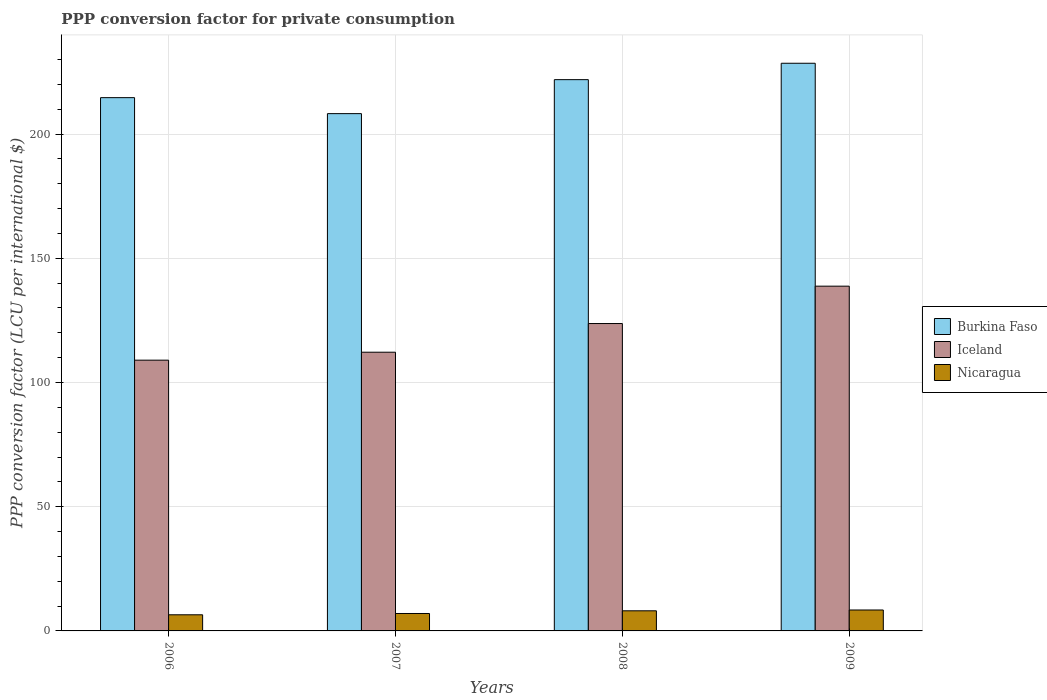How many different coloured bars are there?
Your response must be concise. 3. Are the number of bars per tick equal to the number of legend labels?
Keep it short and to the point. Yes. Are the number of bars on each tick of the X-axis equal?
Give a very brief answer. Yes. What is the label of the 2nd group of bars from the left?
Give a very brief answer. 2007. What is the PPP conversion factor for private consumption in Iceland in 2006?
Keep it short and to the point. 108.99. Across all years, what is the maximum PPP conversion factor for private consumption in Iceland?
Your response must be concise. 138.78. Across all years, what is the minimum PPP conversion factor for private consumption in Nicaragua?
Provide a succinct answer. 6.49. What is the total PPP conversion factor for private consumption in Nicaragua in the graph?
Provide a succinct answer. 30.04. What is the difference between the PPP conversion factor for private consumption in Iceland in 2008 and that in 2009?
Ensure brevity in your answer.  -15.04. What is the difference between the PPP conversion factor for private consumption in Burkina Faso in 2007 and the PPP conversion factor for private consumption in Iceland in 2006?
Offer a terse response. 99.24. What is the average PPP conversion factor for private consumption in Iceland per year?
Your response must be concise. 120.92. In the year 2007, what is the difference between the PPP conversion factor for private consumption in Nicaragua and PPP conversion factor for private consumption in Iceland?
Offer a terse response. -105.17. What is the ratio of the PPP conversion factor for private consumption in Nicaragua in 2006 to that in 2008?
Your answer should be compact. 0.8. Is the difference between the PPP conversion factor for private consumption in Nicaragua in 2007 and 2009 greater than the difference between the PPP conversion factor for private consumption in Iceland in 2007 and 2009?
Offer a very short reply. Yes. What is the difference between the highest and the second highest PPP conversion factor for private consumption in Burkina Faso?
Give a very brief answer. 6.6. What is the difference between the highest and the lowest PPP conversion factor for private consumption in Burkina Faso?
Keep it short and to the point. 20.28. Is the sum of the PPP conversion factor for private consumption in Nicaragua in 2007 and 2009 greater than the maximum PPP conversion factor for private consumption in Burkina Faso across all years?
Your answer should be very brief. No. What does the 3rd bar from the left in 2007 represents?
Provide a succinct answer. Nicaragua. What does the 3rd bar from the right in 2006 represents?
Give a very brief answer. Burkina Faso. Is it the case that in every year, the sum of the PPP conversion factor for private consumption in Burkina Faso and PPP conversion factor for private consumption in Nicaragua is greater than the PPP conversion factor for private consumption in Iceland?
Your answer should be compact. Yes. How many bars are there?
Offer a very short reply. 12. Are all the bars in the graph horizontal?
Offer a terse response. No. How many years are there in the graph?
Ensure brevity in your answer.  4. What is the difference between two consecutive major ticks on the Y-axis?
Your answer should be compact. 50. Are the values on the major ticks of Y-axis written in scientific E-notation?
Your response must be concise. No. Does the graph contain grids?
Your answer should be very brief. Yes. How many legend labels are there?
Keep it short and to the point. 3. How are the legend labels stacked?
Make the answer very short. Vertical. What is the title of the graph?
Give a very brief answer. PPP conversion factor for private consumption. Does "Estonia" appear as one of the legend labels in the graph?
Your answer should be compact. No. What is the label or title of the X-axis?
Provide a short and direct response. Years. What is the label or title of the Y-axis?
Offer a terse response. PPP conversion factor (LCU per international $). What is the PPP conversion factor (LCU per international $) of Burkina Faso in 2006?
Provide a short and direct response. 214.66. What is the PPP conversion factor (LCU per international $) of Iceland in 2006?
Give a very brief answer. 108.99. What is the PPP conversion factor (LCU per international $) of Nicaragua in 2006?
Offer a terse response. 6.49. What is the PPP conversion factor (LCU per international $) in Burkina Faso in 2007?
Keep it short and to the point. 208.23. What is the PPP conversion factor (LCU per international $) in Iceland in 2007?
Keep it short and to the point. 112.19. What is the PPP conversion factor (LCU per international $) of Nicaragua in 2007?
Offer a very short reply. 7.02. What is the PPP conversion factor (LCU per international $) in Burkina Faso in 2008?
Your answer should be very brief. 221.91. What is the PPP conversion factor (LCU per international $) in Iceland in 2008?
Keep it short and to the point. 123.74. What is the PPP conversion factor (LCU per international $) in Nicaragua in 2008?
Offer a very short reply. 8.1. What is the PPP conversion factor (LCU per international $) of Burkina Faso in 2009?
Your answer should be compact. 228.51. What is the PPP conversion factor (LCU per international $) of Iceland in 2009?
Keep it short and to the point. 138.78. What is the PPP conversion factor (LCU per international $) of Nicaragua in 2009?
Your response must be concise. 8.43. Across all years, what is the maximum PPP conversion factor (LCU per international $) of Burkina Faso?
Your response must be concise. 228.51. Across all years, what is the maximum PPP conversion factor (LCU per international $) of Iceland?
Offer a terse response. 138.78. Across all years, what is the maximum PPP conversion factor (LCU per international $) of Nicaragua?
Your answer should be compact. 8.43. Across all years, what is the minimum PPP conversion factor (LCU per international $) in Burkina Faso?
Make the answer very short. 208.23. Across all years, what is the minimum PPP conversion factor (LCU per international $) of Iceland?
Ensure brevity in your answer.  108.99. Across all years, what is the minimum PPP conversion factor (LCU per international $) in Nicaragua?
Offer a very short reply. 6.49. What is the total PPP conversion factor (LCU per international $) in Burkina Faso in the graph?
Provide a succinct answer. 873.3. What is the total PPP conversion factor (LCU per international $) in Iceland in the graph?
Offer a very short reply. 483.7. What is the total PPP conversion factor (LCU per international $) of Nicaragua in the graph?
Give a very brief answer. 30.04. What is the difference between the PPP conversion factor (LCU per international $) in Burkina Faso in 2006 and that in 2007?
Your answer should be very brief. 6.44. What is the difference between the PPP conversion factor (LCU per international $) of Iceland in 2006 and that in 2007?
Offer a terse response. -3.2. What is the difference between the PPP conversion factor (LCU per international $) of Nicaragua in 2006 and that in 2007?
Your answer should be compact. -0.52. What is the difference between the PPP conversion factor (LCU per international $) in Burkina Faso in 2006 and that in 2008?
Your answer should be compact. -7.24. What is the difference between the PPP conversion factor (LCU per international $) of Iceland in 2006 and that in 2008?
Your response must be concise. -14.74. What is the difference between the PPP conversion factor (LCU per international $) in Nicaragua in 2006 and that in 2008?
Give a very brief answer. -1.6. What is the difference between the PPP conversion factor (LCU per international $) in Burkina Faso in 2006 and that in 2009?
Keep it short and to the point. -13.84. What is the difference between the PPP conversion factor (LCU per international $) of Iceland in 2006 and that in 2009?
Offer a very short reply. -29.79. What is the difference between the PPP conversion factor (LCU per international $) in Nicaragua in 2006 and that in 2009?
Give a very brief answer. -1.93. What is the difference between the PPP conversion factor (LCU per international $) of Burkina Faso in 2007 and that in 2008?
Ensure brevity in your answer.  -13.68. What is the difference between the PPP conversion factor (LCU per international $) of Iceland in 2007 and that in 2008?
Your answer should be compact. -11.54. What is the difference between the PPP conversion factor (LCU per international $) of Nicaragua in 2007 and that in 2008?
Give a very brief answer. -1.08. What is the difference between the PPP conversion factor (LCU per international $) of Burkina Faso in 2007 and that in 2009?
Provide a short and direct response. -20.28. What is the difference between the PPP conversion factor (LCU per international $) in Iceland in 2007 and that in 2009?
Your answer should be compact. -26.59. What is the difference between the PPP conversion factor (LCU per international $) of Nicaragua in 2007 and that in 2009?
Make the answer very short. -1.41. What is the difference between the PPP conversion factor (LCU per international $) in Burkina Faso in 2008 and that in 2009?
Your answer should be compact. -6.6. What is the difference between the PPP conversion factor (LCU per international $) of Iceland in 2008 and that in 2009?
Offer a very short reply. -15.04. What is the difference between the PPP conversion factor (LCU per international $) of Nicaragua in 2008 and that in 2009?
Your response must be concise. -0.33. What is the difference between the PPP conversion factor (LCU per international $) in Burkina Faso in 2006 and the PPP conversion factor (LCU per international $) in Iceland in 2007?
Ensure brevity in your answer.  102.47. What is the difference between the PPP conversion factor (LCU per international $) of Burkina Faso in 2006 and the PPP conversion factor (LCU per international $) of Nicaragua in 2007?
Provide a succinct answer. 207.65. What is the difference between the PPP conversion factor (LCU per international $) in Iceland in 2006 and the PPP conversion factor (LCU per international $) in Nicaragua in 2007?
Keep it short and to the point. 101.97. What is the difference between the PPP conversion factor (LCU per international $) in Burkina Faso in 2006 and the PPP conversion factor (LCU per international $) in Iceland in 2008?
Give a very brief answer. 90.93. What is the difference between the PPP conversion factor (LCU per international $) in Burkina Faso in 2006 and the PPP conversion factor (LCU per international $) in Nicaragua in 2008?
Offer a terse response. 206.57. What is the difference between the PPP conversion factor (LCU per international $) in Iceland in 2006 and the PPP conversion factor (LCU per international $) in Nicaragua in 2008?
Offer a terse response. 100.89. What is the difference between the PPP conversion factor (LCU per international $) of Burkina Faso in 2006 and the PPP conversion factor (LCU per international $) of Iceland in 2009?
Give a very brief answer. 75.88. What is the difference between the PPP conversion factor (LCU per international $) in Burkina Faso in 2006 and the PPP conversion factor (LCU per international $) in Nicaragua in 2009?
Make the answer very short. 206.24. What is the difference between the PPP conversion factor (LCU per international $) in Iceland in 2006 and the PPP conversion factor (LCU per international $) in Nicaragua in 2009?
Your answer should be compact. 100.56. What is the difference between the PPP conversion factor (LCU per international $) in Burkina Faso in 2007 and the PPP conversion factor (LCU per international $) in Iceland in 2008?
Your response must be concise. 84.49. What is the difference between the PPP conversion factor (LCU per international $) of Burkina Faso in 2007 and the PPP conversion factor (LCU per international $) of Nicaragua in 2008?
Ensure brevity in your answer.  200.13. What is the difference between the PPP conversion factor (LCU per international $) of Iceland in 2007 and the PPP conversion factor (LCU per international $) of Nicaragua in 2008?
Provide a succinct answer. 104.09. What is the difference between the PPP conversion factor (LCU per international $) in Burkina Faso in 2007 and the PPP conversion factor (LCU per international $) in Iceland in 2009?
Keep it short and to the point. 69.45. What is the difference between the PPP conversion factor (LCU per international $) in Burkina Faso in 2007 and the PPP conversion factor (LCU per international $) in Nicaragua in 2009?
Provide a succinct answer. 199.8. What is the difference between the PPP conversion factor (LCU per international $) of Iceland in 2007 and the PPP conversion factor (LCU per international $) of Nicaragua in 2009?
Give a very brief answer. 103.77. What is the difference between the PPP conversion factor (LCU per international $) of Burkina Faso in 2008 and the PPP conversion factor (LCU per international $) of Iceland in 2009?
Provide a short and direct response. 83.13. What is the difference between the PPP conversion factor (LCU per international $) in Burkina Faso in 2008 and the PPP conversion factor (LCU per international $) in Nicaragua in 2009?
Give a very brief answer. 213.48. What is the difference between the PPP conversion factor (LCU per international $) of Iceland in 2008 and the PPP conversion factor (LCU per international $) of Nicaragua in 2009?
Give a very brief answer. 115.31. What is the average PPP conversion factor (LCU per international $) in Burkina Faso per year?
Your response must be concise. 218.33. What is the average PPP conversion factor (LCU per international $) of Iceland per year?
Offer a terse response. 120.92. What is the average PPP conversion factor (LCU per international $) of Nicaragua per year?
Give a very brief answer. 7.51. In the year 2006, what is the difference between the PPP conversion factor (LCU per international $) in Burkina Faso and PPP conversion factor (LCU per international $) in Iceland?
Ensure brevity in your answer.  105.67. In the year 2006, what is the difference between the PPP conversion factor (LCU per international $) in Burkina Faso and PPP conversion factor (LCU per international $) in Nicaragua?
Give a very brief answer. 208.17. In the year 2006, what is the difference between the PPP conversion factor (LCU per international $) in Iceland and PPP conversion factor (LCU per international $) in Nicaragua?
Provide a succinct answer. 102.5. In the year 2007, what is the difference between the PPP conversion factor (LCU per international $) of Burkina Faso and PPP conversion factor (LCU per international $) of Iceland?
Your answer should be very brief. 96.04. In the year 2007, what is the difference between the PPP conversion factor (LCU per international $) of Burkina Faso and PPP conversion factor (LCU per international $) of Nicaragua?
Ensure brevity in your answer.  201.21. In the year 2007, what is the difference between the PPP conversion factor (LCU per international $) in Iceland and PPP conversion factor (LCU per international $) in Nicaragua?
Your answer should be compact. 105.17. In the year 2008, what is the difference between the PPP conversion factor (LCU per international $) in Burkina Faso and PPP conversion factor (LCU per international $) in Iceland?
Make the answer very short. 98.17. In the year 2008, what is the difference between the PPP conversion factor (LCU per international $) of Burkina Faso and PPP conversion factor (LCU per international $) of Nicaragua?
Offer a very short reply. 213.81. In the year 2008, what is the difference between the PPP conversion factor (LCU per international $) of Iceland and PPP conversion factor (LCU per international $) of Nicaragua?
Your response must be concise. 115.64. In the year 2009, what is the difference between the PPP conversion factor (LCU per international $) in Burkina Faso and PPP conversion factor (LCU per international $) in Iceland?
Make the answer very short. 89.73. In the year 2009, what is the difference between the PPP conversion factor (LCU per international $) in Burkina Faso and PPP conversion factor (LCU per international $) in Nicaragua?
Offer a terse response. 220.08. In the year 2009, what is the difference between the PPP conversion factor (LCU per international $) in Iceland and PPP conversion factor (LCU per international $) in Nicaragua?
Make the answer very short. 130.35. What is the ratio of the PPP conversion factor (LCU per international $) of Burkina Faso in 2006 to that in 2007?
Make the answer very short. 1.03. What is the ratio of the PPP conversion factor (LCU per international $) in Iceland in 2006 to that in 2007?
Offer a terse response. 0.97. What is the ratio of the PPP conversion factor (LCU per international $) of Nicaragua in 2006 to that in 2007?
Your answer should be compact. 0.93. What is the ratio of the PPP conversion factor (LCU per international $) in Burkina Faso in 2006 to that in 2008?
Your answer should be compact. 0.97. What is the ratio of the PPP conversion factor (LCU per international $) of Iceland in 2006 to that in 2008?
Make the answer very short. 0.88. What is the ratio of the PPP conversion factor (LCU per international $) in Nicaragua in 2006 to that in 2008?
Keep it short and to the point. 0.8. What is the ratio of the PPP conversion factor (LCU per international $) in Burkina Faso in 2006 to that in 2009?
Ensure brevity in your answer.  0.94. What is the ratio of the PPP conversion factor (LCU per international $) in Iceland in 2006 to that in 2009?
Your response must be concise. 0.79. What is the ratio of the PPP conversion factor (LCU per international $) in Nicaragua in 2006 to that in 2009?
Give a very brief answer. 0.77. What is the ratio of the PPP conversion factor (LCU per international $) in Burkina Faso in 2007 to that in 2008?
Provide a succinct answer. 0.94. What is the ratio of the PPP conversion factor (LCU per international $) in Iceland in 2007 to that in 2008?
Your response must be concise. 0.91. What is the ratio of the PPP conversion factor (LCU per international $) in Nicaragua in 2007 to that in 2008?
Your answer should be very brief. 0.87. What is the ratio of the PPP conversion factor (LCU per international $) of Burkina Faso in 2007 to that in 2009?
Offer a terse response. 0.91. What is the ratio of the PPP conversion factor (LCU per international $) of Iceland in 2007 to that in 2009?
Keep it short and to the point. 0.81. What is the ratio of the PPP conversion factor (LCU per international $) in Nicaragua in 2007 to that in 2009?
Offer a very short reply. 0.83. What is the ratio of the PPP conversion factor (LCU per international $) in Burkina Faso in 2008 to that in 2009?
Your answer should be very brief. 0.97. What is the ratio of the PPP conversion factor (LCU per international $) in Iceland in 2008 to that in 2009?
Your answer should be compact. 0.89. What is the difference between the highest and the second highest PPP conversion factor (LCU per international $) in Burkina Faso?
Offer a very short reply. 6.6. What is the difference between the highest and the second highest PPP conversion factor (LCU per international $) in Iceland?
Your answer should be compact. 15.04. What is the difference between the highest and the second highest PPP conversion factor (LCU per international $) of Nicaragua?
Offer a very short reply. 0.33. What is the difference between the highest and the lowest PPP conversion factor (LCU per international $) in Burkina Faso?
Keep it short and to the point. 20.28. What is the difference between the highest and the lowest PPP conversion factor (LCU per international $) in Iceland?
Provide a succinct answer. 29.79. What is the difference between the highest and the lowest PPP conversion factor (LCU per international $) in Nicaragua?
Provide a short and direct response. 1.93. 